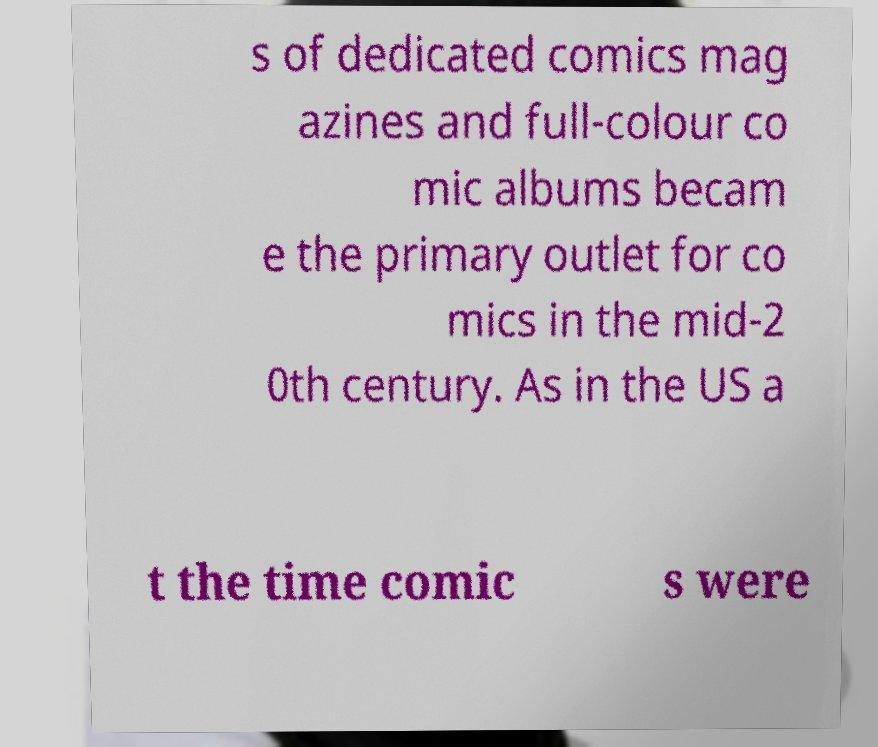For documentation purposes, I need the text within this image transcribed. Could you provide that? s of dedicated comics mag azines and full-colour co mic albums becam e the primary outlet for co mics in the mid-2 0th century. As in the US a t the time comic s were 